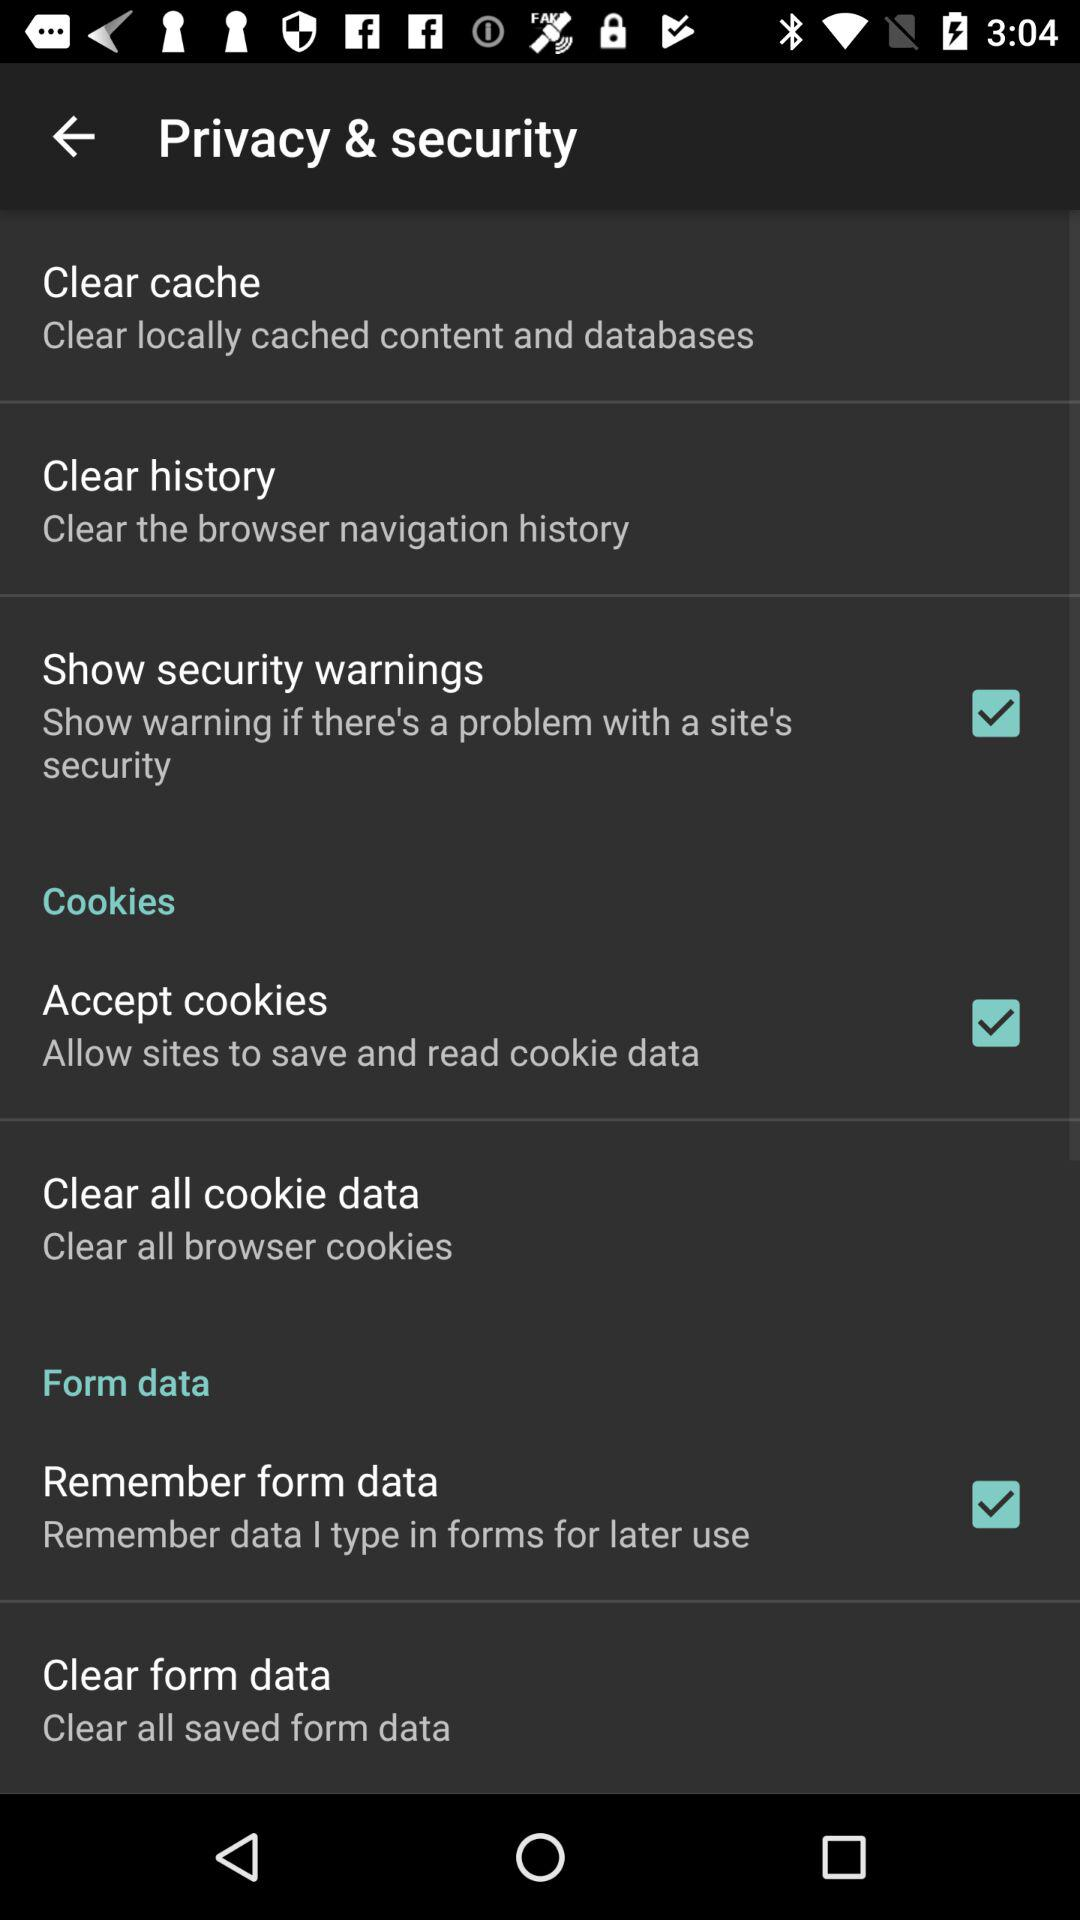What is the status of "Accept cookies"? The status of "Accept cookies" is "on". 